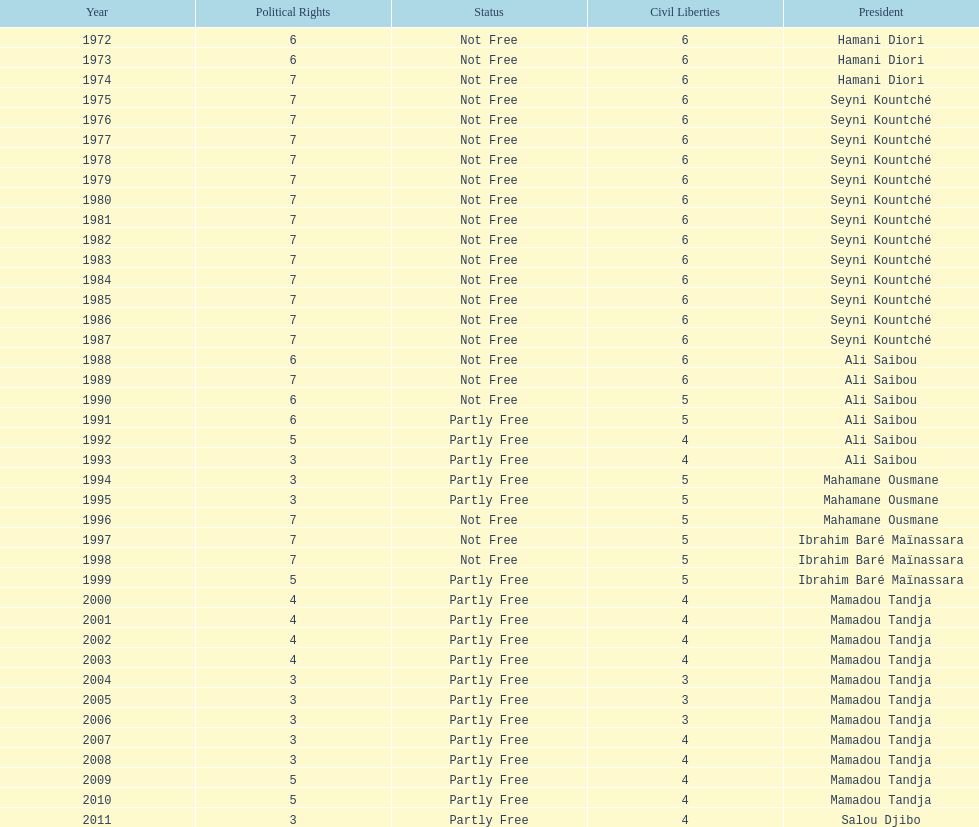Give me the full table as a dictionary. {'header': ['Year', 'Political Rights', 'Status', 'Civil Liberties', 'President'], 'rows': [['1972', '6', 'Not Free', '6', 'Hamani Diori'], ['1973', '6', 'Not Free', '6', 'Hamani Diori'], ['1974', '7', 'Not Free', '6', 'Hamani Diori'], ['1975', '7', 'Not Free', '6', 'Seyni Kountché'], ['1976', '7', 'Not Free', '6', 'Seyni Kountché'], ['1977', '7', 'Not Free', '6', 'Seyni Kountché'], ['1978', '7', 'Not Free', '6', 'Seyni Kountché'], ['1979', '7', 'Not Free', '6', 'Seyni Kountché'], ['1980', '7', 'Not Free', '6', 'Seyni Kountché'], ['1981', '7', 'Not Free', '6', 'Seyni Kountché'], ['1982', '7', 'Not Free', '6', 'Seyni Kountché'], ['1983', '7', 'Not Free', '6', 'Seyni Kountché'], ['1984', '7', 'Not Free', '6', 'Seyni Kountché'], ['1985', '7', 'Not Free', '6', 'Seyni Kountché'], ['1986', '7', 'Not Free', '6', 'Seyni Kountché'], ['1987', '7', 'Not Free', '6', 'Seyni Kountché'], ['1988', '6', 'Not Free', '6', 'Ali Saibou'], ['1989', '7', 'Not Free', '6', 'Ali Saibou'], ['1990', '6', 'Not Free', '5', 'Ali Saibou'], ['1991', '6', 'Partly Free', '5', 'Ali Saibou'], ['1992', '5', 'Partly Free', '4', 'Ali Saibou'], ['1993', '3', 'Partly Free', '4', 'Ali Saibou'], ['1994', '3', 'Partly Free', '5', 'Mahamane Ousmane'], ['1995', '3', 'Partly Free', '5', 'Mahamane Ousmane'], ['1996', '7', 'Not Free', '5', 'Mahamane Ousmane'], ['1997', '7', 'Not Free', '5', 'Ibrahim Baré Maïnassara'], ['1998', '7', 'Not Free', '5', 'Ibrahim Baré Maïnassara'], ['1999', '5', 'Partly Free', '5', 'Ibrahim Baré Maïnassara'], ['2000', '4', 'Partly Free', '4', 'Mamadou Tandja'], ['2001', '4', 'Partly Free', '4', 'Mamadou Tandja'], ['2002', '4', 'Partly Free', '4', 'Mamadou Tandja'], ['2003', '4', 'Partly Free', '4', 'Mamadou Tandja'], ['2004', '3', 'Partly Free', '3', 'Mamadou Tandja'], ['2005', '3', 'Partly Free', '3', 'Mamadou Tandja'], ['2006', '3', 'Partly Free', '3', 'Mamadou Tandja'], ['2007', '3', 'Partly Free', '4', 'Mamadou Tandja'], ['2008', '3', 'Partly Free', '4', 'Mamadou Tandja'], ['2009', '5', 'Partly Free', '4', 'Mamadou Tandja'], ['2010', '5', 'Partly Free', '4', 'Mamadou Tandja'], ['2011', '3', 'Partly Free', '4', 'Salou Djibo']]} Who is the next president listed after hamani diori in the year 1974? Seyni Kountché. 